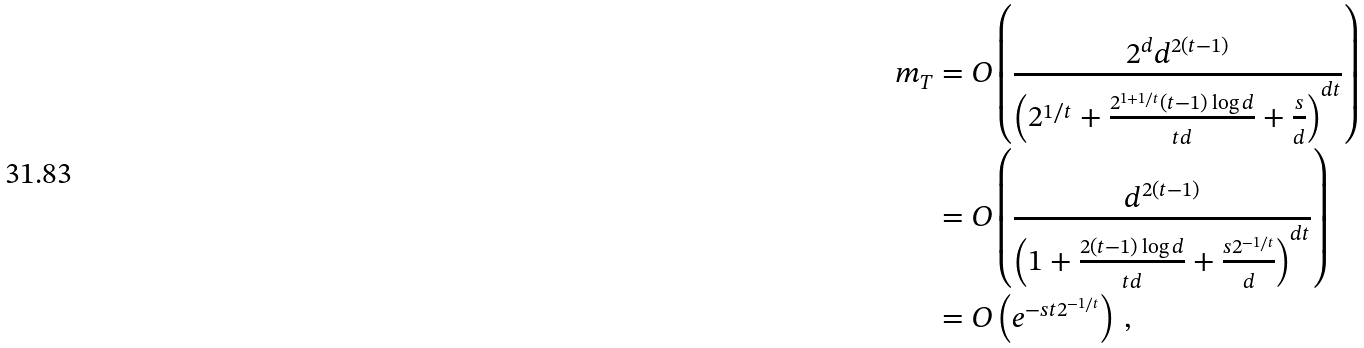<formula> <loc_0><loc_0><loc_500><loc_500>m _ { T } & = O \left ( \frac { 2 ^ { d } d ^ { 2 ( t - 1 ) } } { \left ( 2 ^ { 1 / t } + \frac { 2 ^ { 1 + 1 / t } ( t - 1 ) \log d } { t d } + \frac { s } { d } \right ) ^ { d t } } \right ) \\ & = O \left ( \frac { d ^ { 2 ( t - 1 ) } } { \left ( 1 + \frac { 2 ( t - 1 ) \log d } { t d } + \frac { s 2 ^ { - 1 / t } } { d } \right ) ^ { d t } } \right ) \\ & = O \left ( e ^ { - s t 2 ^ { - 1 / t } } \right ) \, ,</formula> 